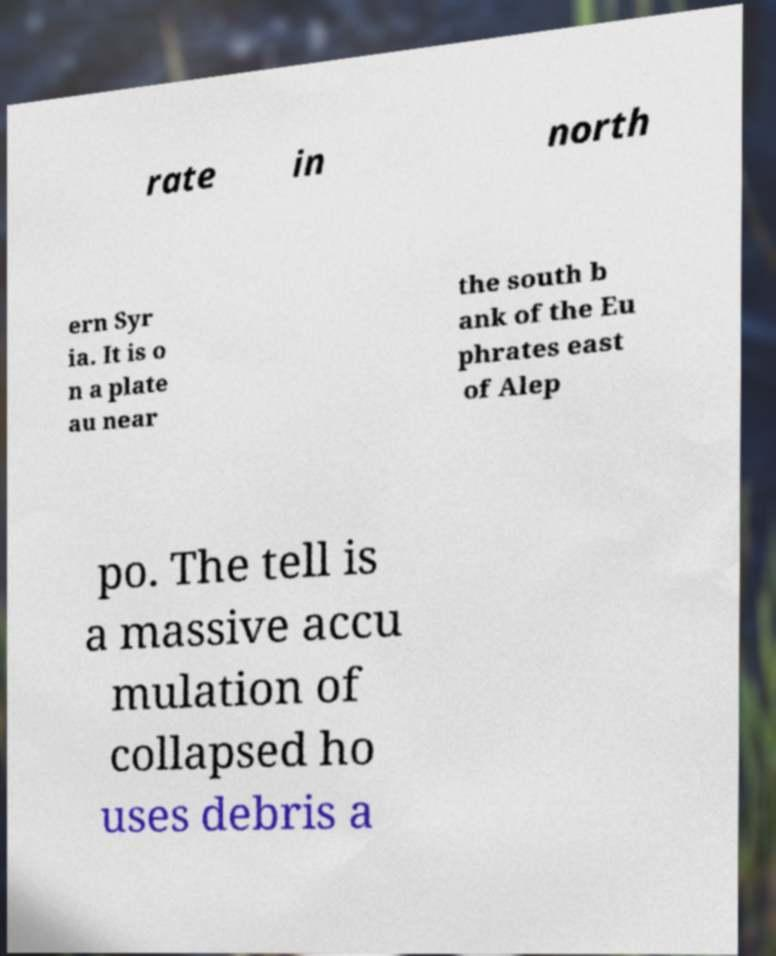Please read and relay the text visible in this image. What does it say? rate in north ern Syr ia. It is o n a plate au near the south b ank of the Eu phrates east of Alep po. The tell is a massive accu mulation of collapsed ho uses debris a 